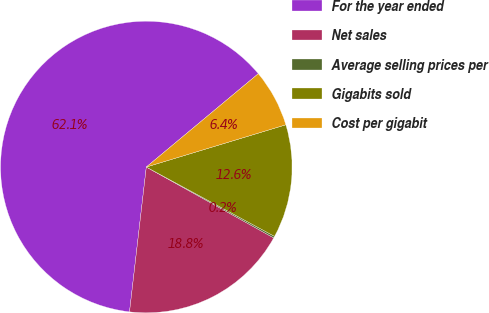<chart> <loc_0><loc_0><loc_500><loc_500><pie_chart><fcel>For the year ended<fcel>Net sales<fcel>Average selling prices per<fcel>Gigabits sold<fcel>Cost per gigabit<nl><fcel>62.11%<fcel>18.76%<fcel>0.19%<fcel>12.57%<fcel>6.38%<nl></chart> 